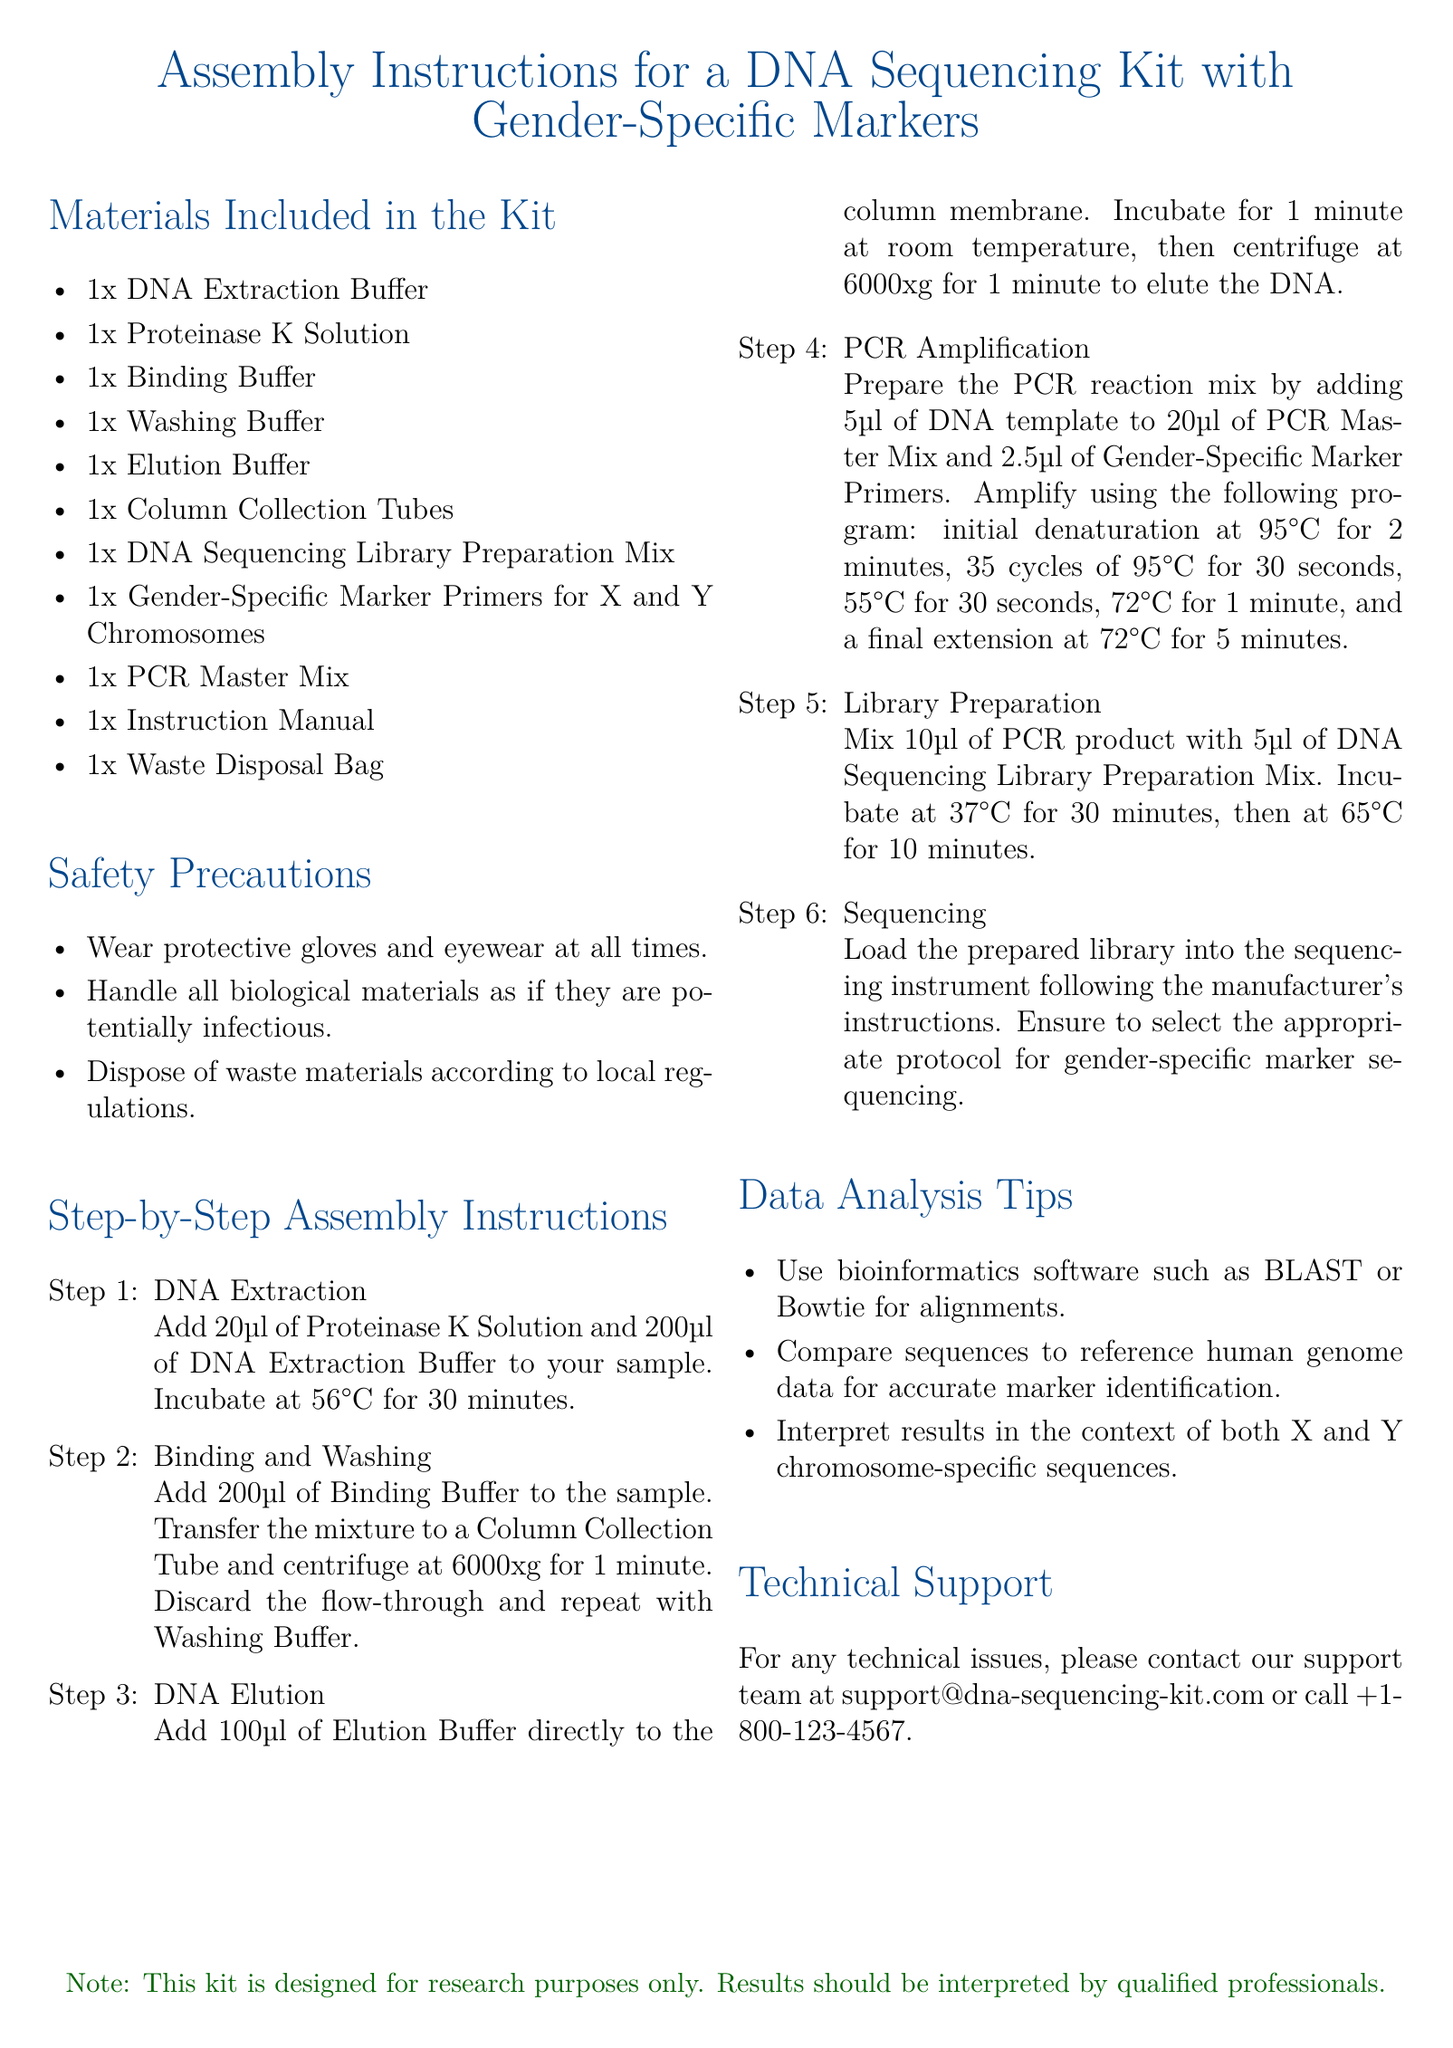What is included in the kit? The kit includes several materials necessary for DNA sequencing, listed in the "Materials Included in the Kit" section.
Answer: DNA Extraction Buffer, Proteinase K Solution, Binding Buffer, Washing Buffer, Elution Buffer, Column Collection Tubes, DNA Sequencing Library Preparation Mix, Gender-Specific Marker Primers for X and Y Chromosomes, PCR Master Mix, Instruction Manual, Waste Disposal Bag How many steps are there in the assembly instructions? The document lists six specific steps in the "Step-by-Step Assembly Instructions" section.
Answer: 6 What is the temperature for the initial denaturation in PCR Amplification? The initial denaturation temperature is specified in the PCR Amplification step, referenced within the instructions.
Answer: 95°C Which software is recommended for alignments? The "Data Analysis Tips" section recommends specific software for analysis purposes.
Answer: BLAST or Bowtie What should be done after incubating the PCR product at 37°C? The next action after incubating is specified, indicating the subsequent step in library preparation.
Answer: Incubate at 65°C for 10 minutes What is the note on usage at the bottom of the document? The note clarifies the intended use and interpretation of results in the kit.
Answer: This kit is designed for research purposes only 